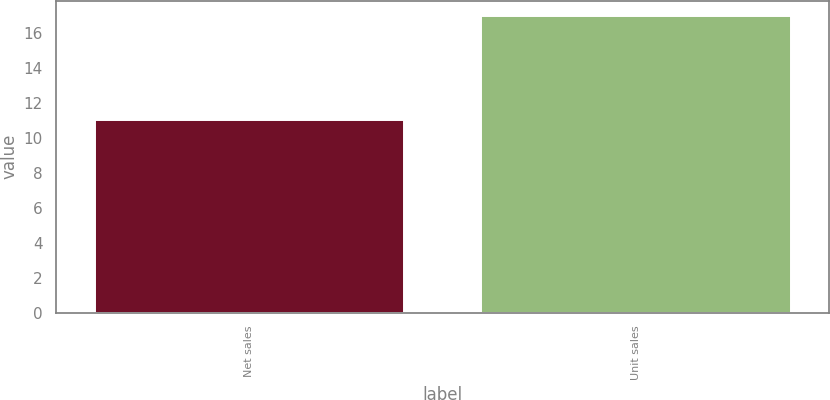Convert chart. <chart><loc_0><loc_0><loc_500><loc_500><bar_chart><fcel>Net sales<fcel>Unit sales<nl><fcel>11<fcel>17<nl></chart> 